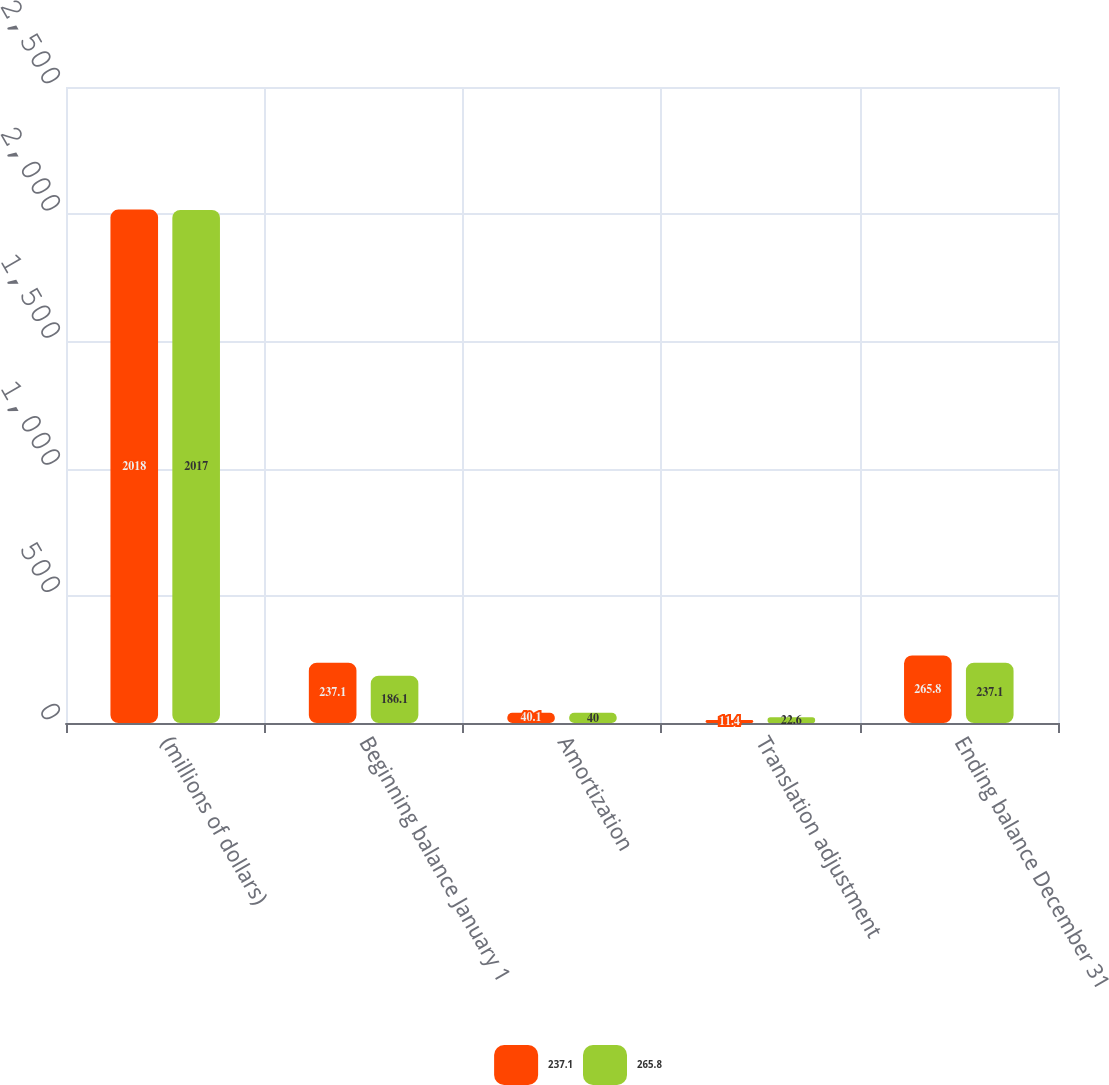<chart> <loc_0><loc_0><loc_500><loc_500><stacked_bar_chart><ecel><fcel>(millions of dollars)<fcel>Beginning balance January 1<fcel>Amortization<fcel>Translation adjustment<fcel>Ending balance December 31<nl><fcel>237.1<fcel>2018<fcel>237.1<fcel>40.1<fcel>11.4<fcel>265.8<nl><fcel>265.8<fcel>2017<fcel>186.1<fcel>40<fcel>22.6<fcel>237.1<nl></chart> 